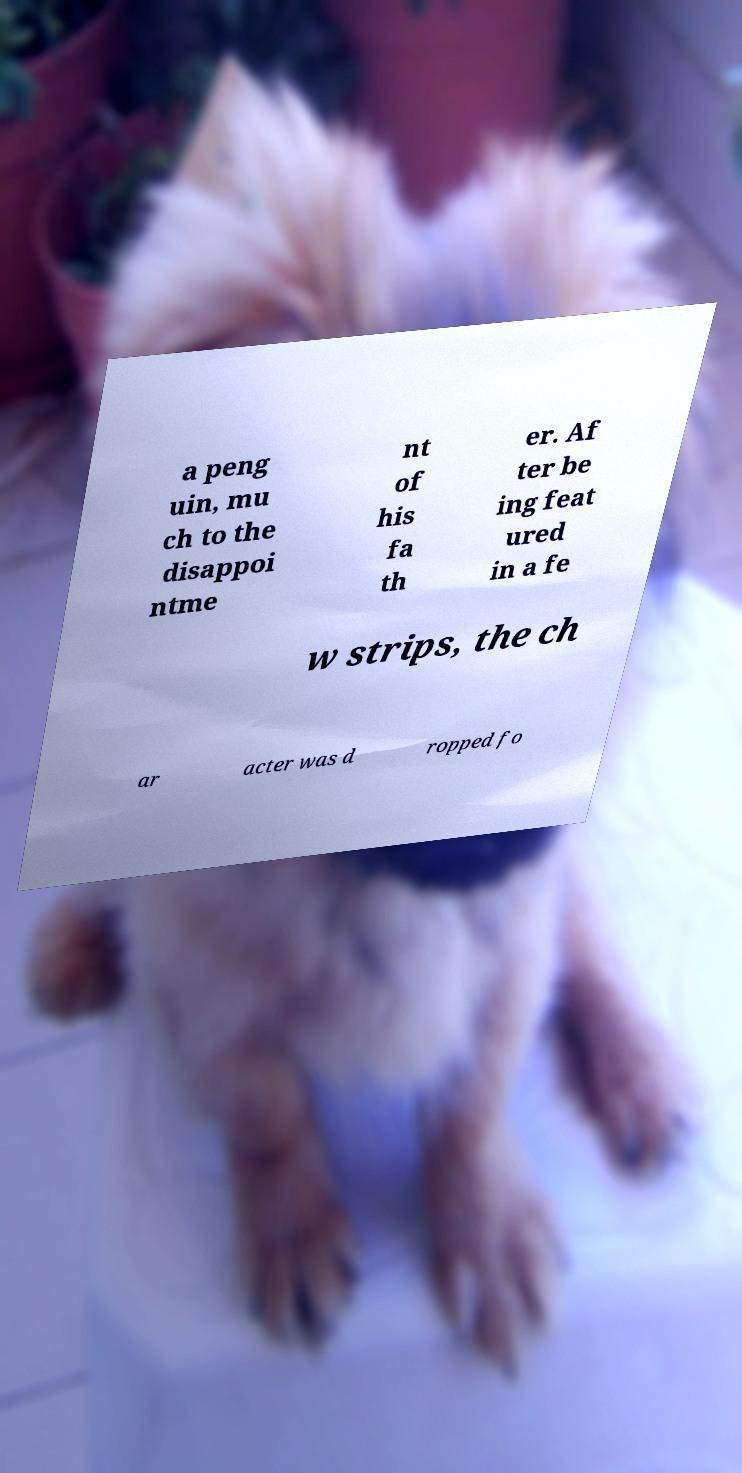I need the written content from this picture converted into text. Can you do that? a peng uin, mu ch to the disappoi ntme nt of his fa th er. Af ter be ing feat ured in a fe w strips, the ch ar acter was d ropped fo 